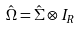<formula> <loc_0><loc_0><loc_500><loc_500>\hat { \Omega } = \hat { \Sigma } \otimes I _ { R }</formula> 